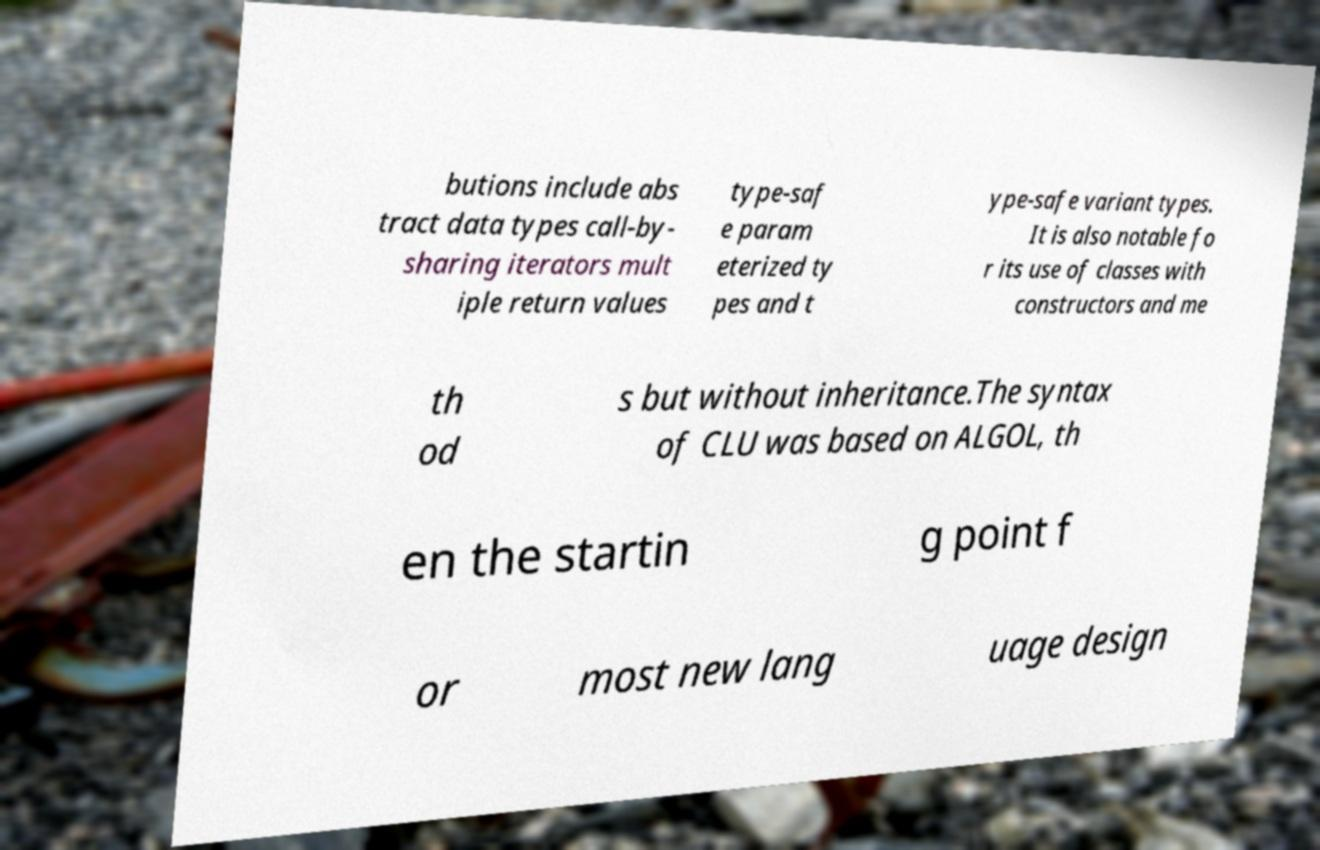For documentation purposes, I need the text within this image transcribed. Could you provide that? butions include abs tract data types call-by- sharing iterators mult iple return values type-saf e param eterized ty pes and t ype-safe variant types. It is also notable fo r its use of classes with constructors and me th od s but without inheritance.The syntax of CLU was based on ALGOL, th en the startin g point f or most new lang uage design 